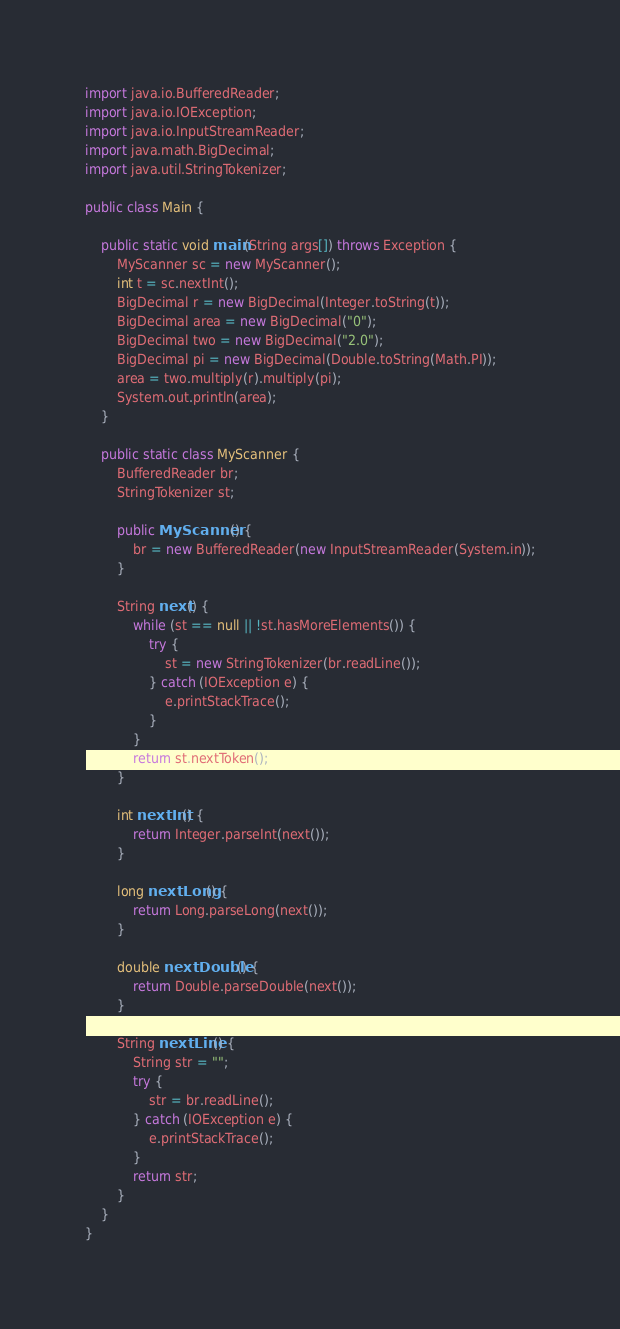Convert code to text. <code><loc_0><loc_0><loc_500><loc_500><_Java_>

import java.io.BufferedReader;
import java.io.IOException;
import java.io.InputStreamReader;
import java.math.BigDecimal;
import java.util.StringTokenizer;

public class Main {

	public static void main(String args[]) throws Exception {
		MyScanner sc = new MyScanner();
		int t = sc.nextInt();
		BigDecimal r = new BigDecimal(Integer.toString(t));
		BigDecimal area = new BigDecimal("0");
		BigDecimal two = new BigDecimal("2.0");
		BigDecimal pi = new BigDecimal(Double.toString(Math.PI));
		area = two.multiply(r).multiply(pi);
		System.out.println(area);
	}

	public static class MyScanner {
		BufferedReader br;
		StringTokenizer st;

		public MyScanner() {
			br = new BufferedReader(new InputStreamReader(System.in));
		}

		String next() {
			while (st == null || !st.hasMoreElements()) {
				try {
					st = new StringTokenizer(br.readLine());
				} catch (IOException e) {
					e.printStackTrace();
				}
			}
			return st.nextToken();
		}

		int nextInt() {
			return Integer.parseInt(next());
		}

		long nextLong() {
			return Long.parseLong(next());
		}

		double nextDouble() {
			return Double.parseDouble(next());
		}

		String nextLine() {
			String str = "";
			try {
				str = br.readLine();
			} catch (IOException e) {
				e.printStackTrace();
			}
			return str;
		}
	}
}</code> 